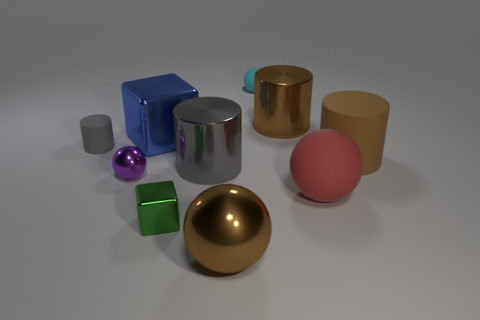Subtract 1 balls. How many balls are left? 3 Subtract all balls. How many objects are left? 6 Subtract all large gray metal blocks. Subtract all large brown objects. How many objects are left? 7 Add 3 purple shiny things. How many purple shiny things are left? 4 Add 8 small rubber spheres. How many small rubber spheres exist? 9 Subtract 0 brown blocks. How many objects are left? 10 